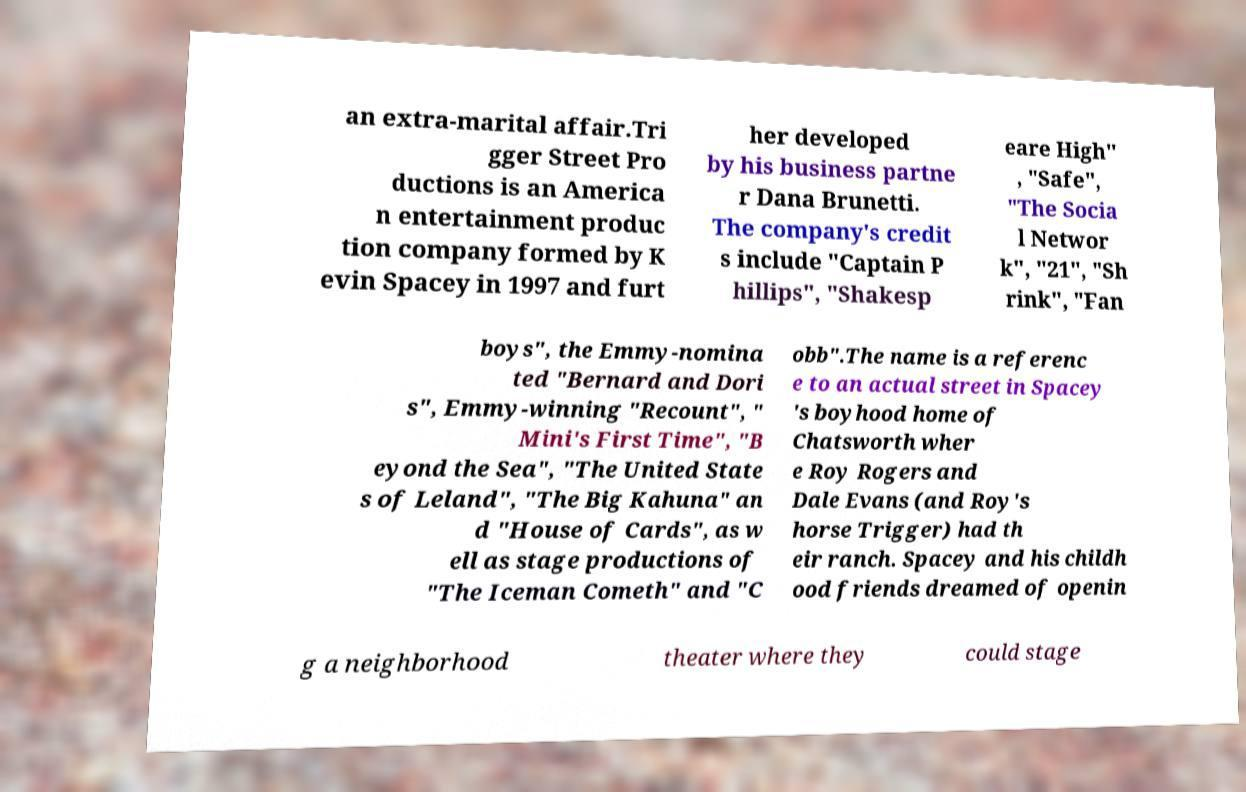Can you accurately transcribe the text from the provided image for me? an extra-marital affair.Tri gger Street Pro ductions is an America n entertainment produc tion company formed by K evin Spacey in 1997 and furt her developed by his business partne r Dana Brunetti. The company's credit s include "Captain P hillips", "Shakesp eare High" , "Safe", "The Socia l Networ k", "21", "Sh rink", "Fan boys", the Emmy-nomina ted "Bernard and Dori s", Emmy-winning "Recount", " Mini's First Time", "B eyond the Sea", "The United State s of Leland", "The Big Kahuna" an d "House of Cards", as w ell as stage productions of "The Iceman Cometh" and "C obb".The name is a referenc e to an actual street in Spacey 's boyhood home of Chatsworth wher e Roy Rogers and Dale Evans (and Roy's horse Trigger) had th eir ranch. Spacey and his childh ood friends dreamed of openin g a neighborhood theater where they could stage 